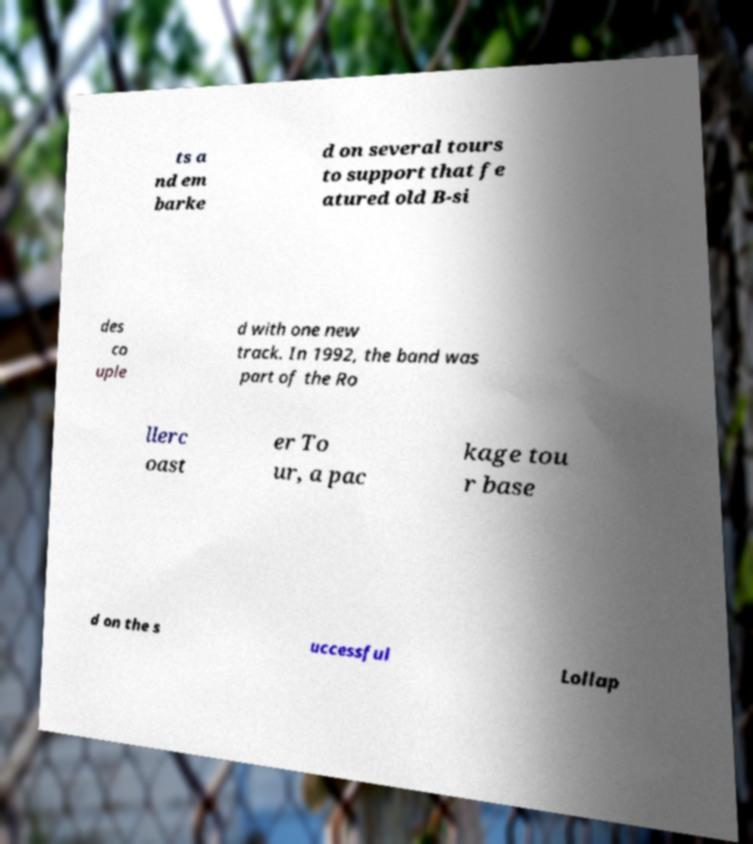Please read and relay the text visible in this image. What does it say? ts a nd em barke d on several tours to support that fe atured old B-si des co uple d with one new track. In 1992, the band was part of the Ro llerc oast er To ur, a pac kage tou r base d on the s uccessful Lollap 